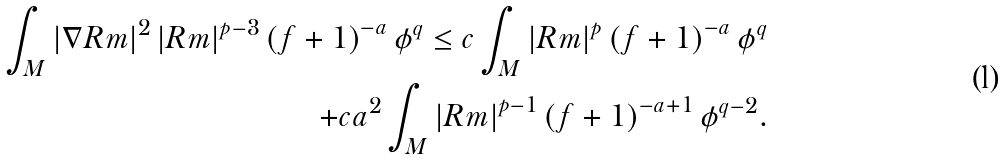Convert formula to latex. <formula><loc_0><loc_0><loc_500><loc_500>\int _ { M } \left | \nabla R m \right | ^ { 2 } \left | R m \right | ^ { p - 3 } \left ( f + 1 \right ) ^ { - a } \phi ^ { q } \leq c \int _ { M } \left | R m \right | ^ { p } \left ( f + 1 \right ) ^ { - a } \phi ^ { q } \\ + c a ^ { 2 } \int _ { M } \left | R m \right | ^ { p - 1 } \left ( f + 1 \right ) ^ { - a + 1 } \phi ^ { q - 2 } .</formula> 